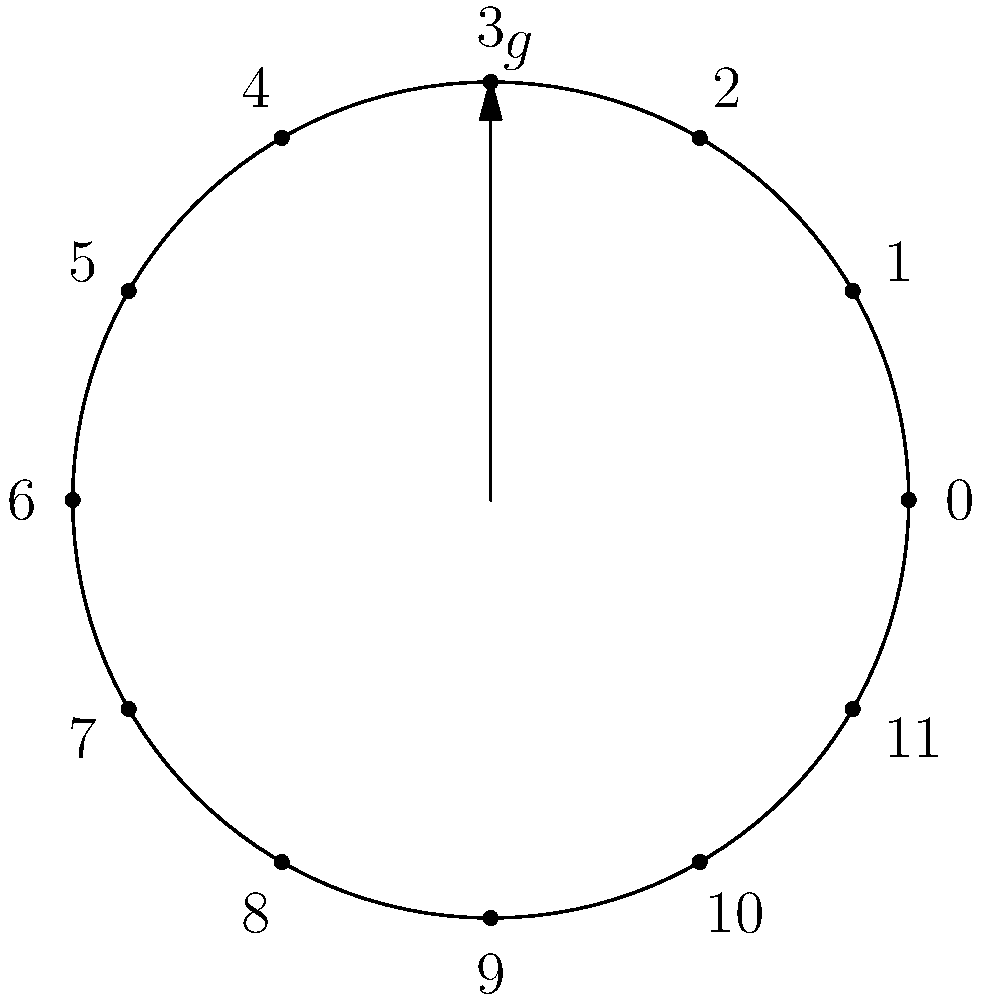Consider the cyclic group $C_{12}$ represented by a clock arithmetic diagram. If $g$ is the generator that rotates the clock hand by 90 degrees clockwise (3 hours), what is the order of the element $g^2$? How does this relate to the concept of subgroups in group theory? To solve this problem, let's follow these steps:

1) First, we need to understand what $g^2$ means in this context:
   - $g$ rotates the clock hand by 90 degrees (3 hours) clockwise
   - $g^2$ would rotate the clock hand by 180 degrees (6 hours) clockwise

2) To find the order of $g^2$, we need to determine how many times we need to apply $g^2$ to get back to the starting position:
   - $g^2$: 0 → 6
   - $(g^2)^2$: 6 → 0

3) We see that $(g^2)^2 = e$ (the identity element), where $e$ represents no rotation

4) Therefore, the order of $g^2$ is 2

5) Relating this to subgroups:
   - The element $g^2$ generates a subgroup of $C_{12}$
   - This subgroup consists of the elements $\{e, g^2\}$
   - It's isomorphic to $C_2$, the cyclic group of order 2

6) This demonstrates an important concept in group theory:
   - The order of a subgroup must divide the order of the group
   - Here, 2 (order of $\langle g^2 \rangle$) divides 12 (order of $C_{12}$)

7) Moreover, this example illustrates how cyclic groups can have cyclic subgroups, which is a fundamental property in the study of group structures and their relationships.
Answer: The order of $g^2$ is 2, generating a subgroup isomorphic to $C_2$. 